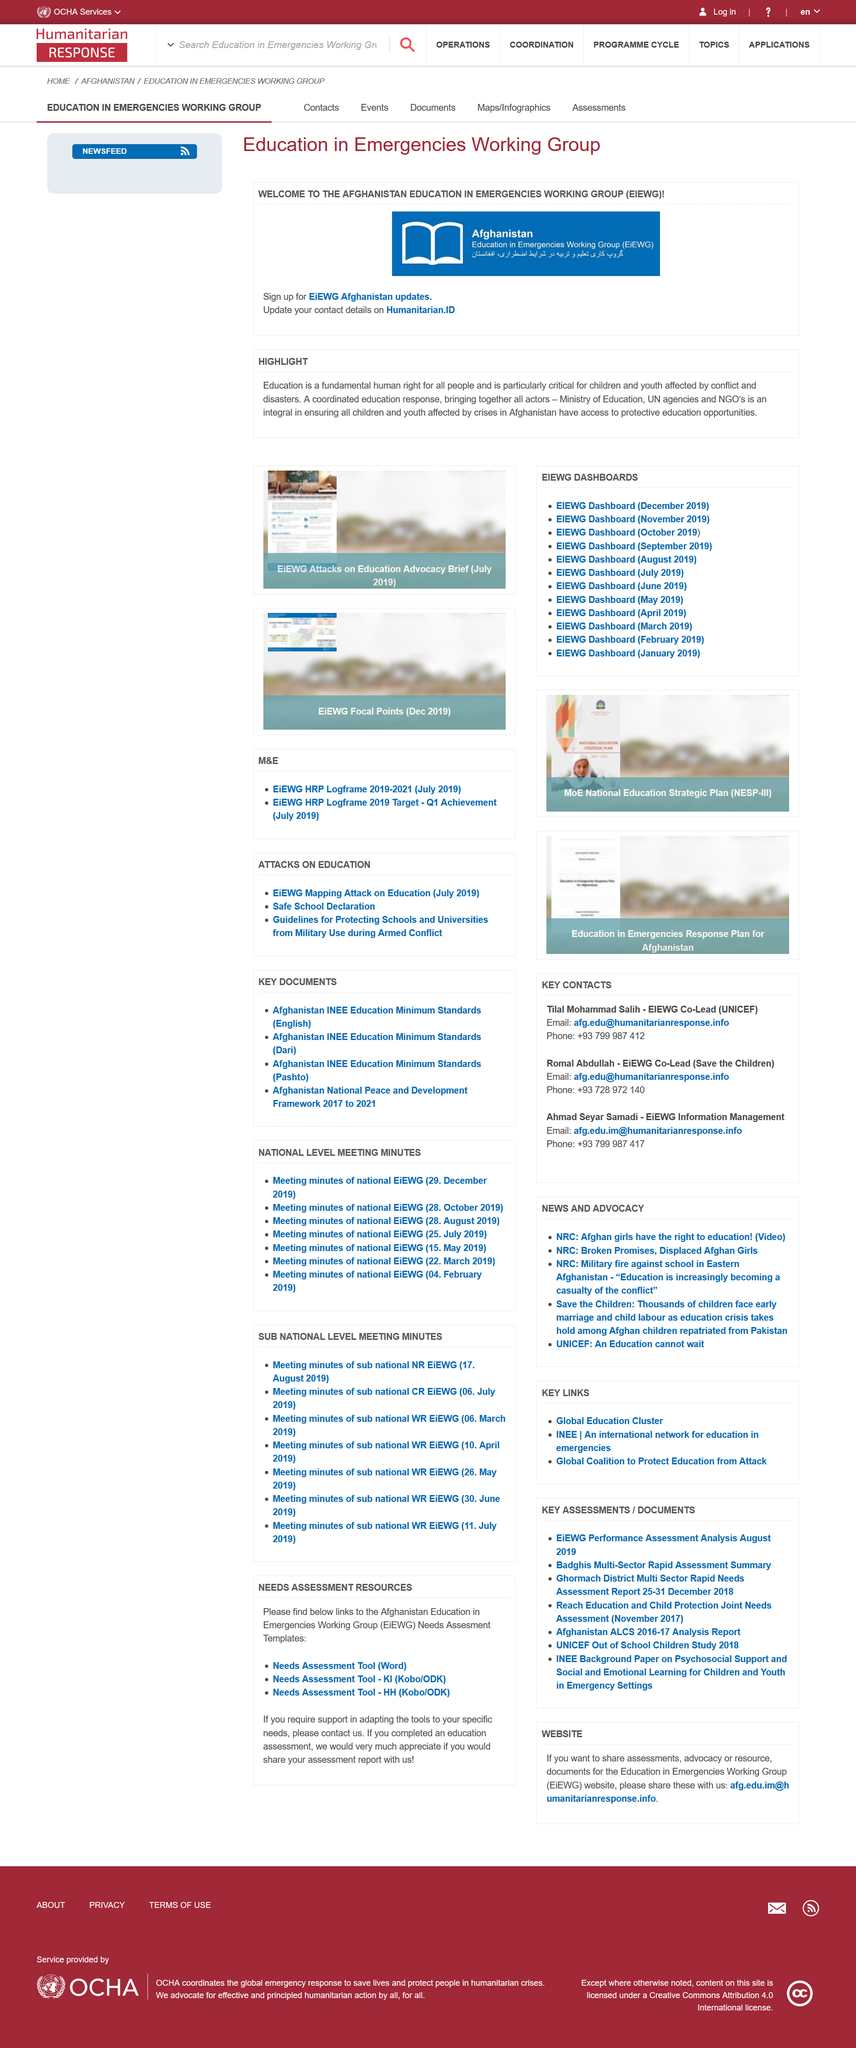Highlight a few significant elements in this photo. Education being a fundamental right is a highlight and a crucial aspect of our society. Education is a fundamental human right for all people, which is essential for the full development and well-being of individuals and society as a whole. EIEWG stands for Education in Emergencies Working Group, which is dedicated to providing education and support in times of crisis. 